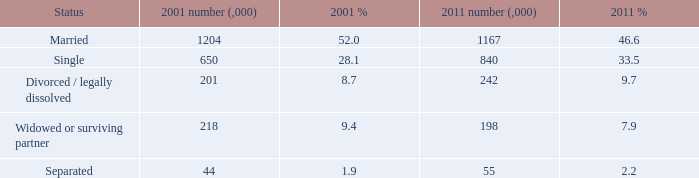What is the 2001 % for the status widowed or surviving partner? 9.4. 